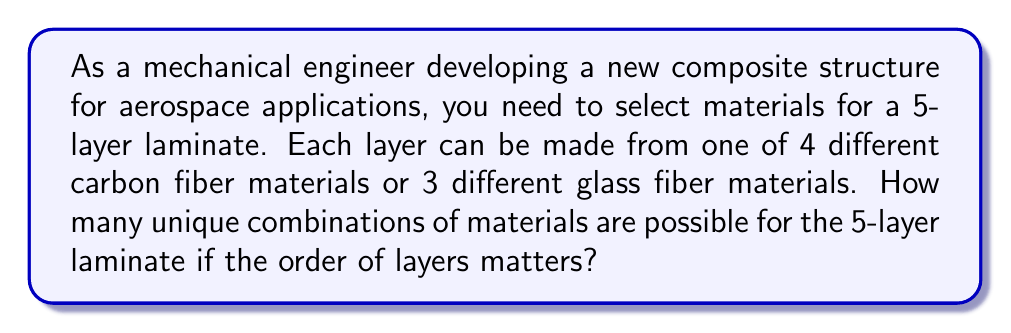What is the answer to this math problem? Let's approach this step-by-step:

1) First, we need to identify the total number of material choices for each layer:
   - 4 carbon fiber materials
   - 3 glass fiber materials
   Total choices per layer = 4 + 3 = 7

2) Since the order of layers matters, this is a problem of ordered selection with replacement. We are selecting 5 times (for 5 layers) from 7 options, and we can reuse the same material multiple times if needed.

3) This scenario is described by the multiplication principle. For each layer, we have 7 choices, and we make this choice 5 times independently.

4) Mathematically, this can be expressed as:

   $$ \text{Total combinations} = 7^5 $$

5) Let's calculate this:
   $$ 7^5 = 7 \times 7 \times 7 \times 7 \times 7 = 16,807 $$

Therefore, there are 16,807 unique combinations of materials possible for the 5-layer laminate.
Answer: 16,807 